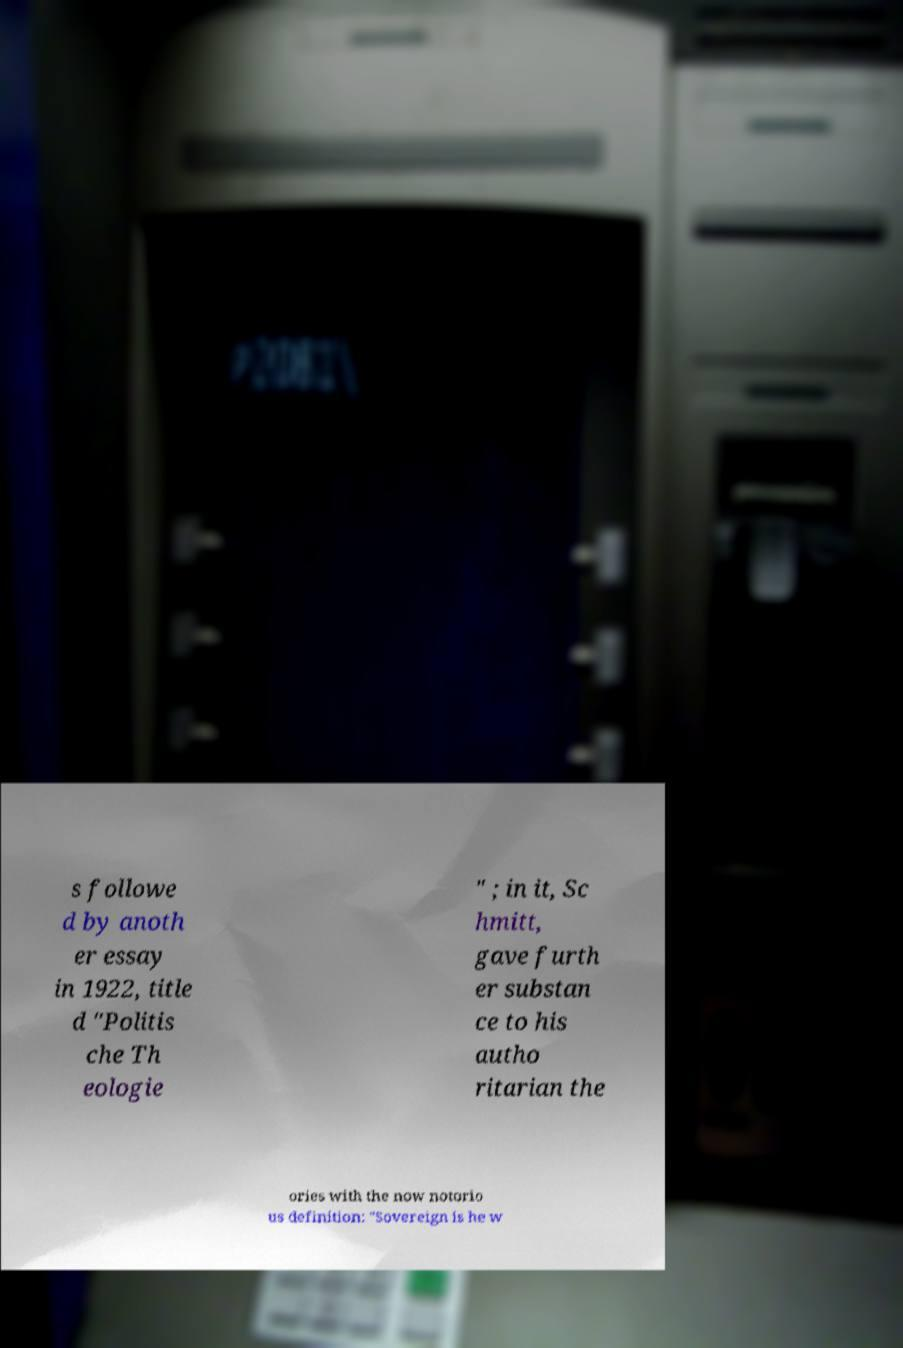Can you accurately transcribe the text from the provided image for me? s followe d by anoth er essay in 1922, title d "Politis che Th eologie " ; in it, Sc hmitt, gave furth er substan ce to his autho ritarian the ories with the now notorio us definition: "Sovereign is he w 